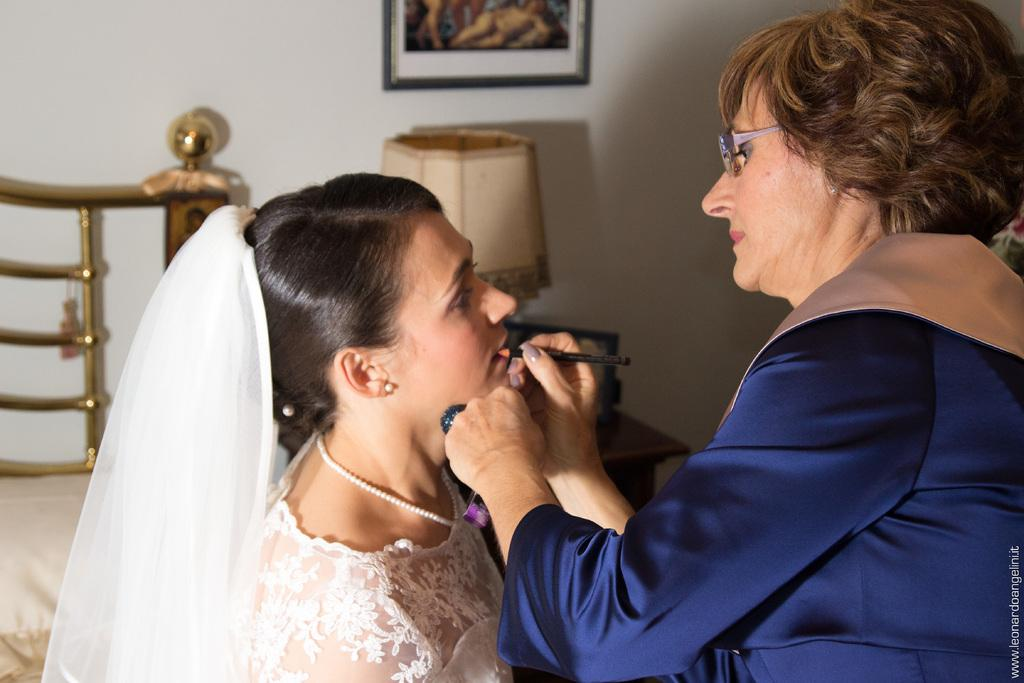Who is the main subject in the image? There is a woman in the image. What is the woman wearing? The woman is wearing a white dress. What is the woman doing in the image? The woman is sitting. Who is present in front of the woman? There is a make-up artist in front of the woman. What can be seen in the background of the image? There are other objects in the background of the image. What channel is the woman watching on the TV in the image? There is no TV present in the image, so it is not possible to determine what channel the woman might be watching. 